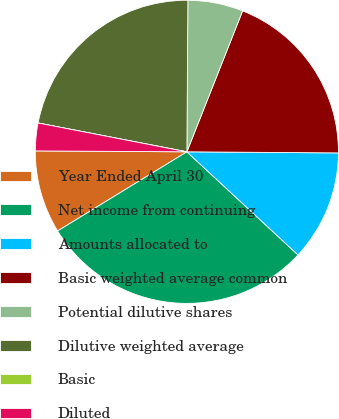Convert chart. <chart><loc_0><loc_0><loc_500><loc_500><pie_chart><fcel>Year Ended April 30<fcel>Net income from continuing<fcel>Amounts allocated to<fcel>Basic weighted average common<fcel>Potential dilutive shares<fcel>Dilutive weighted average<fcel>Basic<fcel>Diluted<nl><fcel>8.84%<fcel>29.35%<fcel>11.79%<fcel>19.12%<fcel>5.89%<fcel>22.06%<fcel>0.0%<fcel>2.95%<nl></chart> 